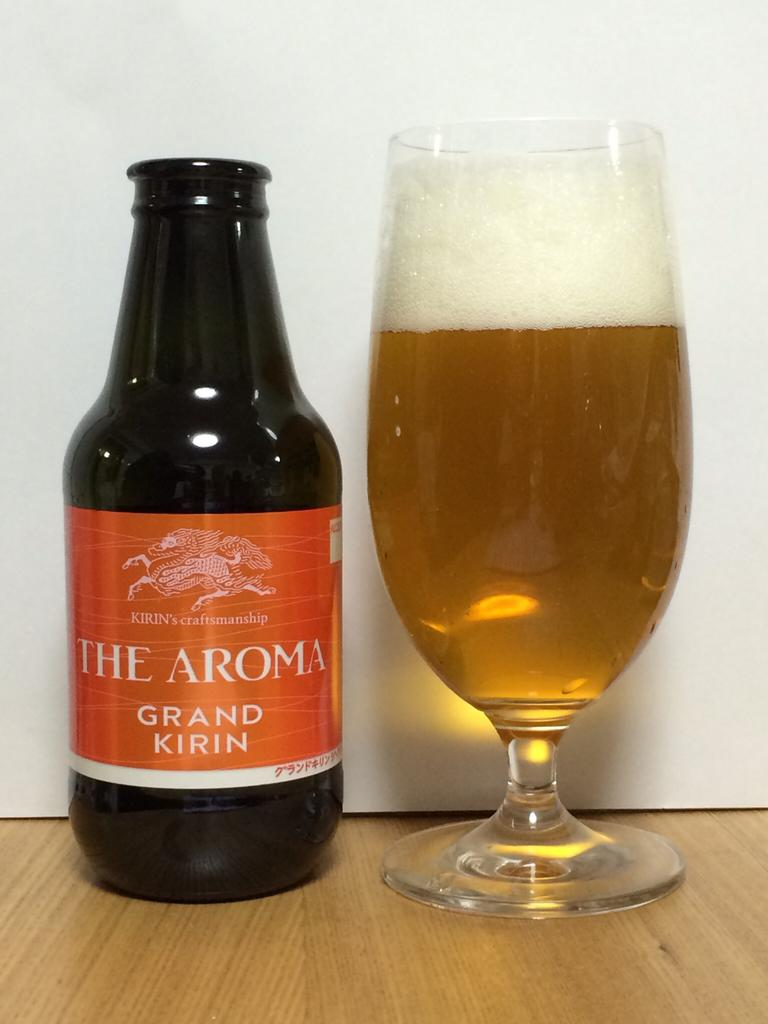<image>
Provide a brief description of the given image. A bottle of The Aroma grand kirin sits next to a full glass on a table. 